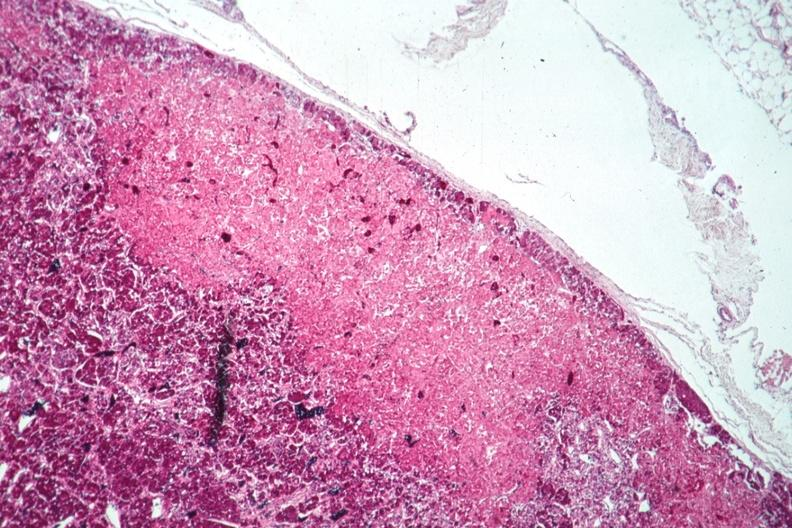s cachexia present?
Answer the question using a single word or phrase. No 